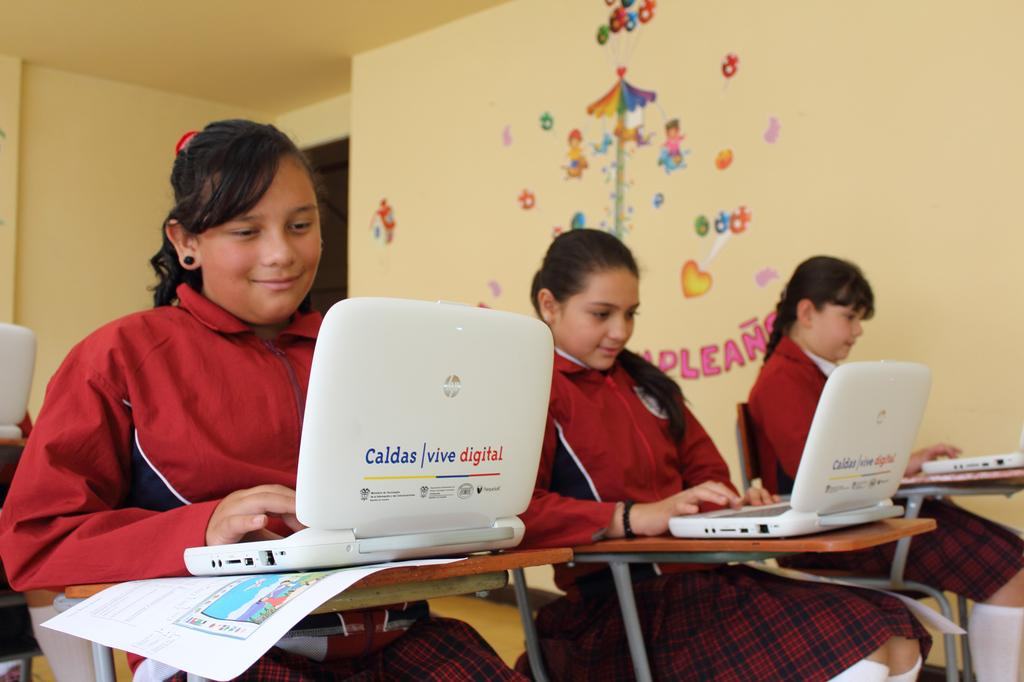Who is present in the image? There are girls in the image. What are the girls doing in the image? The girls are sitting on chairs. What object is on the table in front of the girls? There is a laptop on a table in front of the girls. How many geese are visible in the image? There are no geese present in the image. What type of knowledge can be gained from the laptop in the image? The image does not provide any information about the content of the laptop, so it cannot be determined what type of knowledge might be gained from it. 